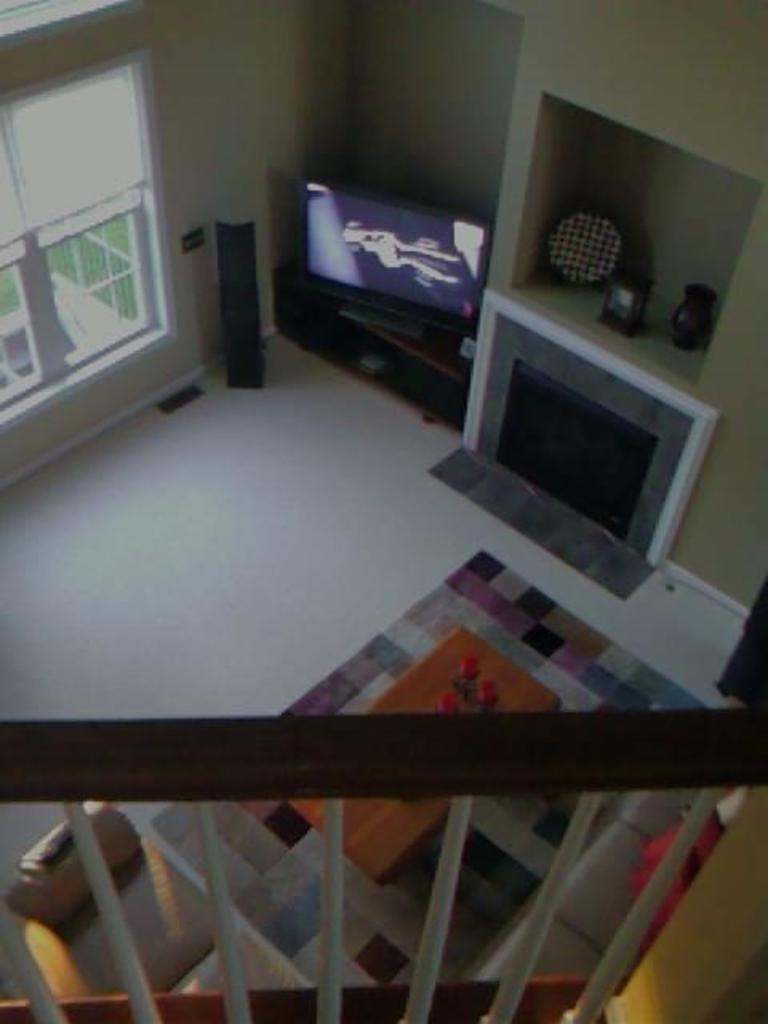What electronic device is present in the image? There is a television in the image. What architectural feature is visible in the image? There are stairs in the image. What type of heating appliance can be seen in the image? There is a fireplace in the image. What is the color of the wall in the image? The wall color is cream. What type of window is present in the image? There is a glass window in the image. How many oranges are on the fireplace mantle in the image? There are no oranges present in the image. Is there a bear visible through the glass window in the image? There is no bear visible through the glass window in the image. 